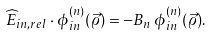<formula> <loc_0><loc_0><loc_500><loc_500>\widehat { E } _ { i n , r e l } \cdot \phi ^ { ( n ) } _ { i n } ( \vec { \varrho } ) = - B _ { n } \, \phi ^ { ( n ) } _ { i n } ( \vec { \varrho } ) .</formula> 